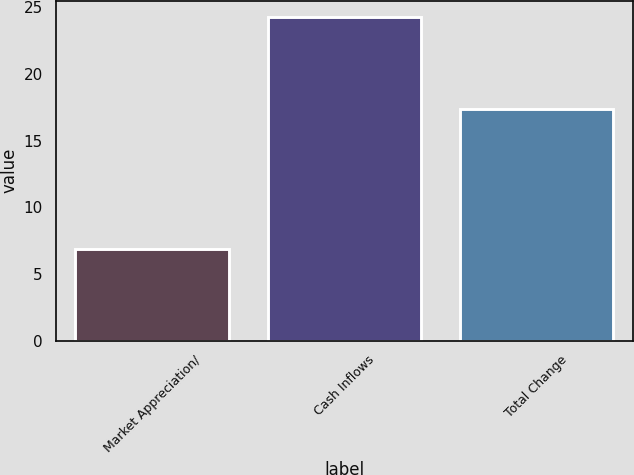Convert chart. <chart><loc_0><loc_0><loc_500><loc_500><bar_chart><fcel>Market Appreciation/<fcel>Cash Inflows<fcel>Total Change<nl><fcel>6.9<fcel>24.3<fcel>17.4<nl></chart> 